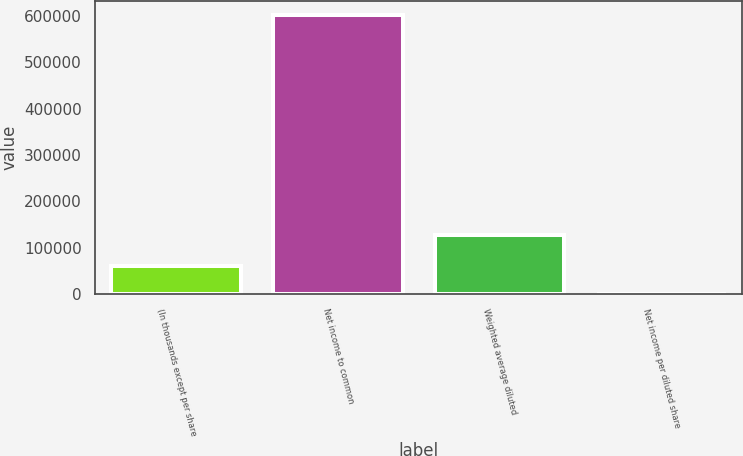Convert chart to OTSL. <chart><loc_0><loc_0><loc_500><loc_500><bar_chart><fcel>(In thousands except per share<fcel>Net income to common<fcel>Weighted average diluted<fcel>Net income per diluted share<nl><fcel>60195.8<fcel>601916<fcel>128553<fcel>4.68<nl></chart> 